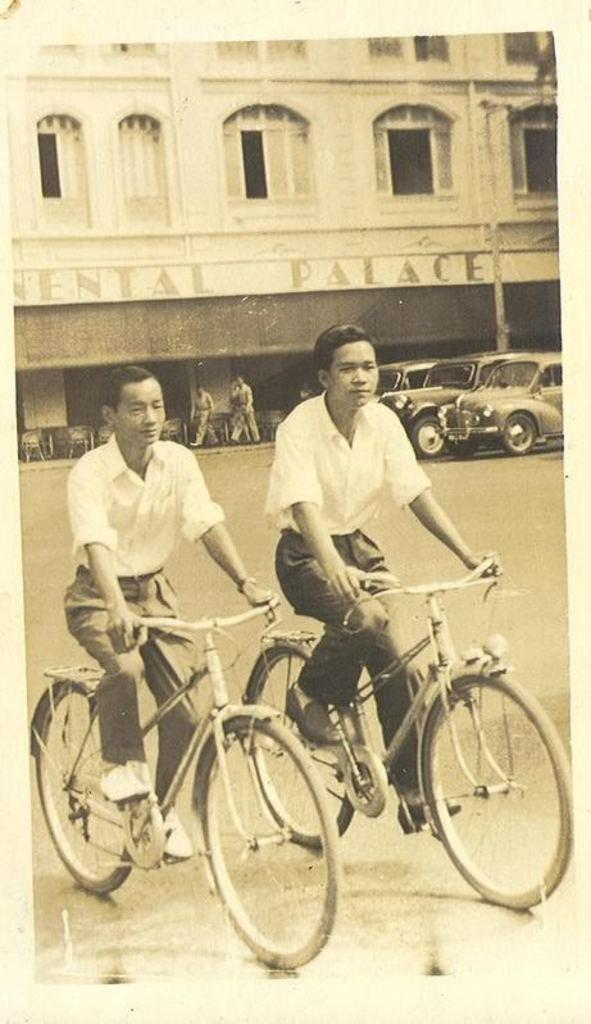How many people are riding the bicycle in the image? There are two persons riding a bicycle in the image. What are the other people in the image doing? There are remaining people walking in the background. What can be seen in the background of the image? There is a building, a tree, and a pole in the background. What type of advice can be heard from the cow in the image? There is no cow present in the image, so it is not possible to hear any advice from a cow. 